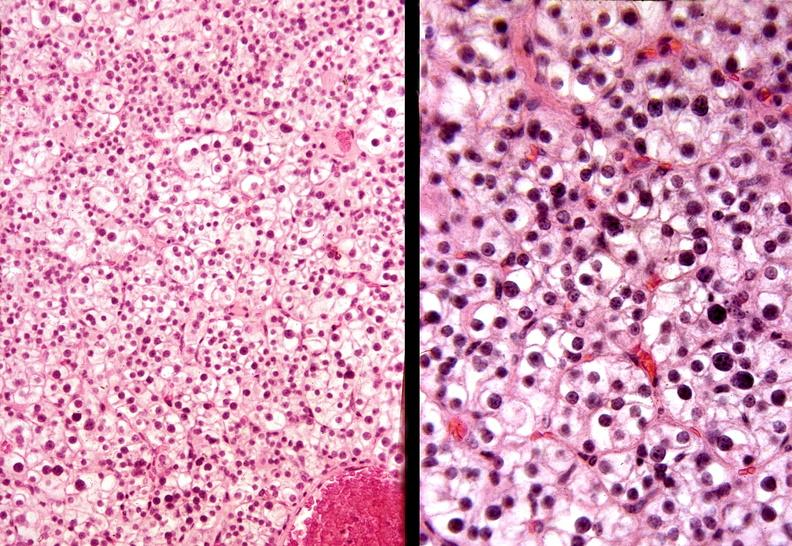s endocrine present?
Answer the question using a single word or phrase. Yes 